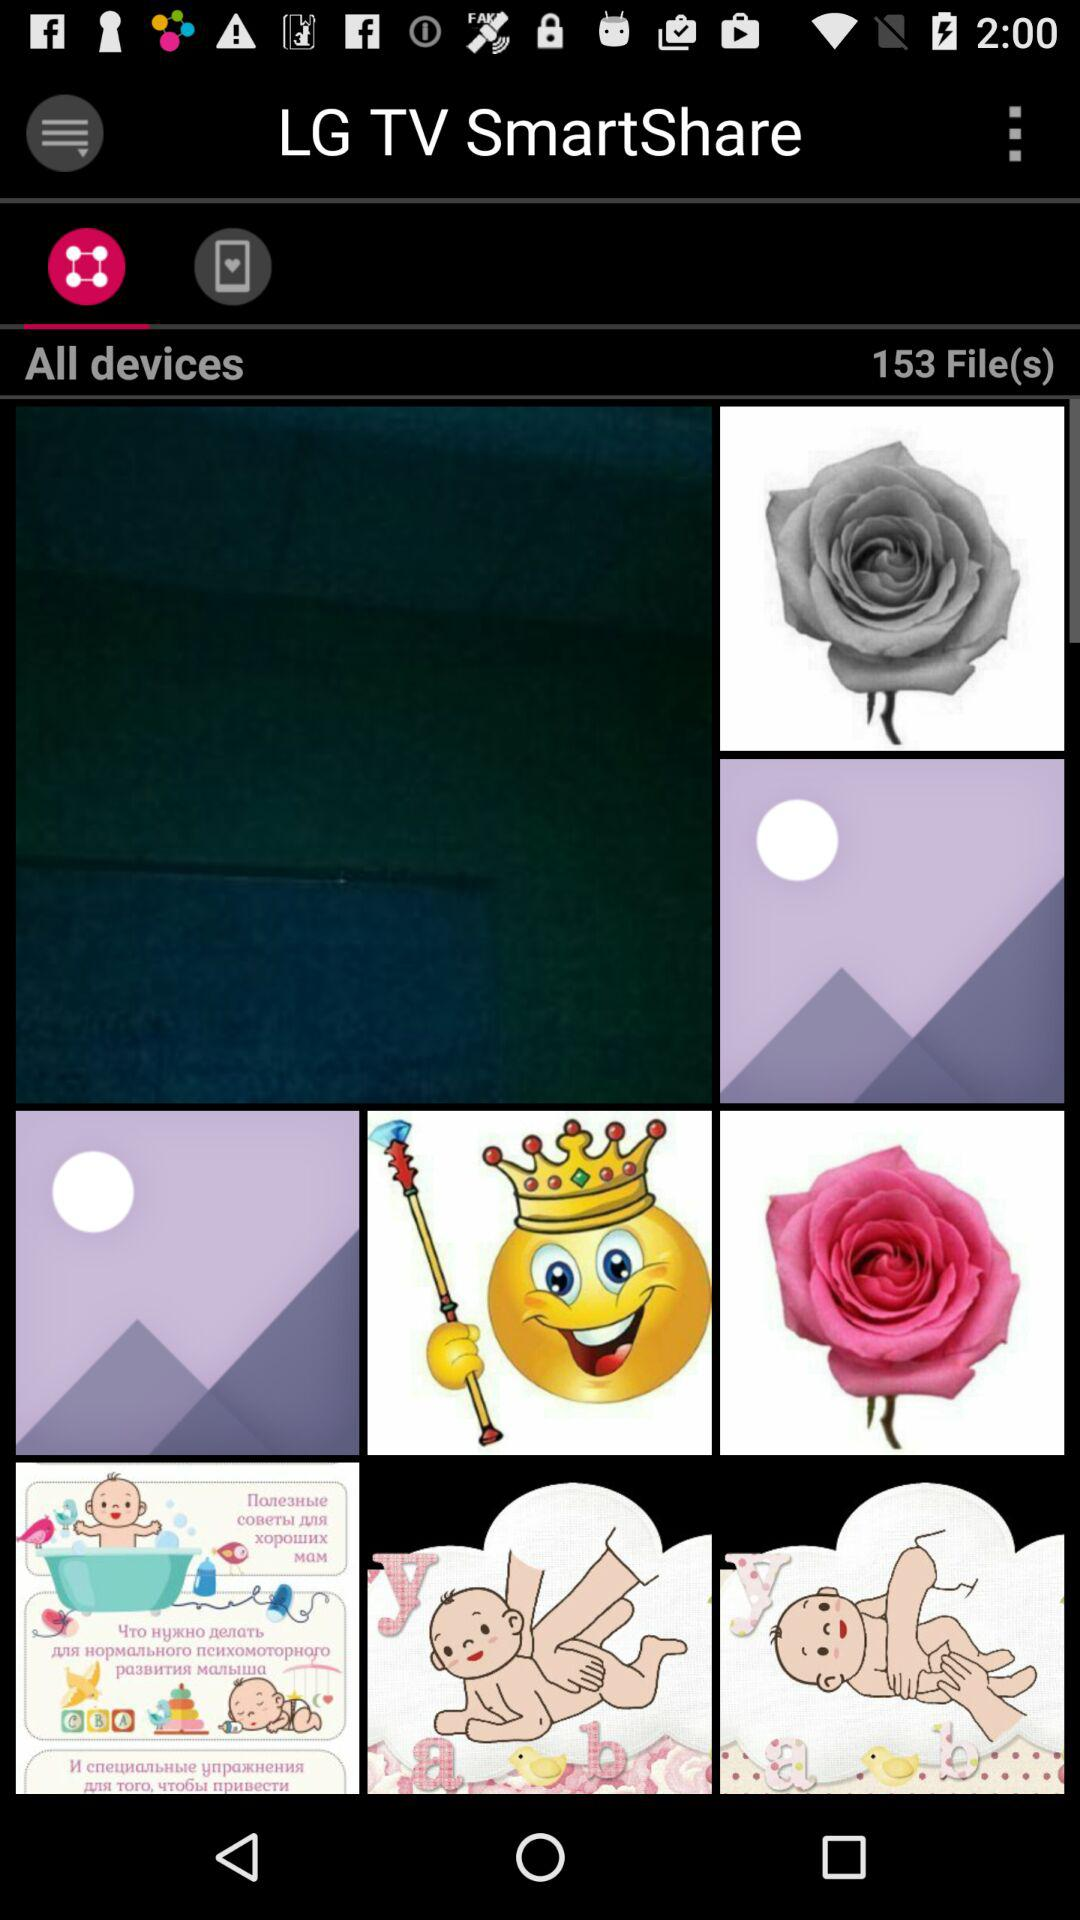What is the file count? The file count is 153. 